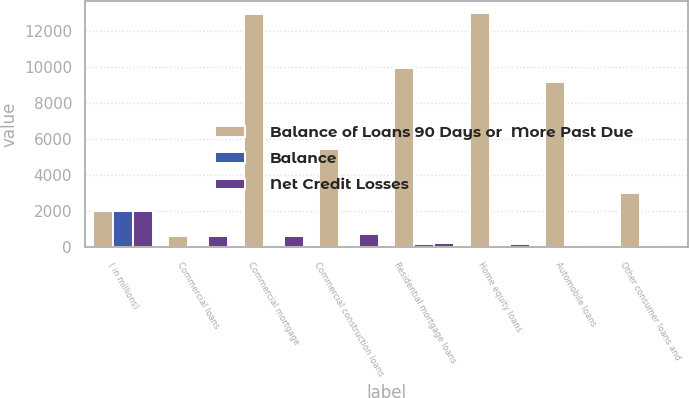Convert chart. <chart><loc_0><loc_0><loc_500><loc_500><stacked_bar_chart><ecel><fcel>( in millions)<fcel>Commercial loans<fcel>Commercial mortgage<fcel>Commercial construction loans<fcel>Residential mortgage loans<fcel>Home equity loans<fcel>Automobile loans<fcel>Other consumer loans and<nl><fcel>Balance of Loans 90 Days or  More Past Due<fcel>2008<fcel>613<fcel>12952<fcel>5477<fcel>9946<fcel>13025<fcel>9183<fcel>3006<nl><fcel>Balance<fcel>2008<fcel>76<fcel>136<fcel>74<fcel>198<fcel>98<fcel>22<fcel>57<nl><fcel>Net Credit Losses<fcel>2008<fcel>649<fcel>613<fcel>749<fcel>242<fcel>207<fcel>141<fcel>118<nl></chart> 